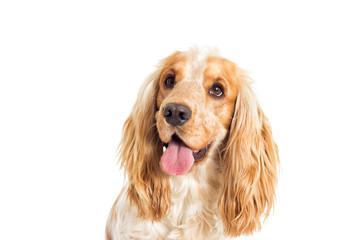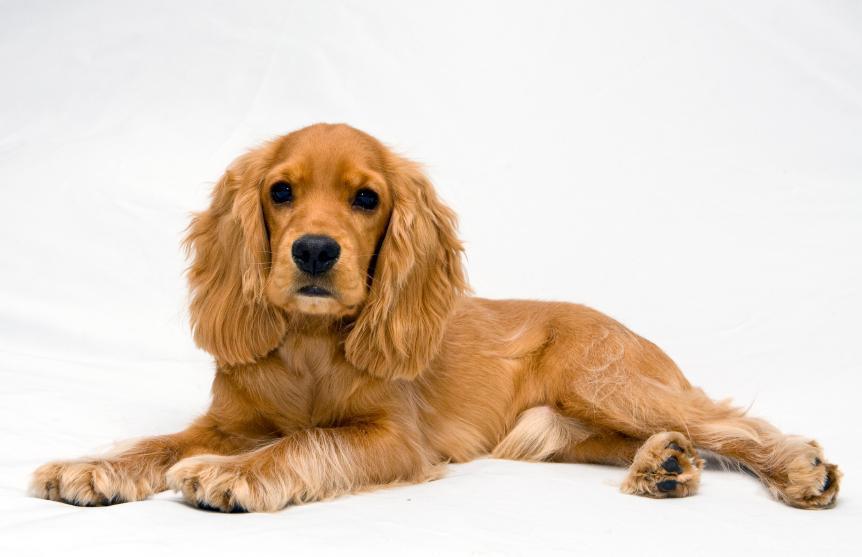The first image is the image on the left, the second image is the image on the right. For the images shown, is this caption "The dog in one of the images is looking straight into the camera." true? Answer yes or no. Yes. 